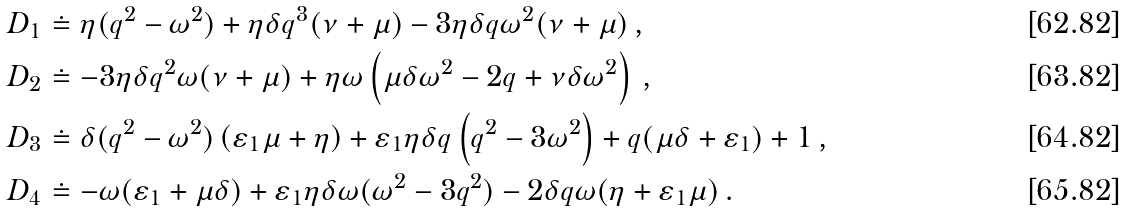<formula> <loc_0><loc_0><loc_500><loc_500>D _ { 1 } & \doteq \eta ( q ^ { 2 } - \omega ^ { 2 } ) + \eta \delta q ^ { 3 } ( \nu + \mu ) - 3 \eta \delta q \omega ^ { 2 } ( \nu + \mu ) \, , \\ D _ { 2 } & \doteq - 3 \eta \delta q ^ { 2 } \omega ( \nu + \mu ) + \eta \omega \left ( \mu \delta \omega ^ { 2 } - 2 q + \nu \delta \omega ^ { 2 } \right ) \, , \\ D _ { 3 } & \doteq \delta ( q ^ { 2 } - \omega ^ { 2 } ) \left ( \varepsilon _ { 1 } \mu + \eta \right ) + \varepsilon _ { 1 } \eta \delta q \left ( q ^ { 2 } - 3 \omega ^ { 2 } \right ) + q ( \mu \delta + \varepsilon _ { 1 } ) + 1 \, , \\ D _ { 4 } & \doteq - \omega ( \varepsilon _ { 1 } + \mu \delta ) + \varepsilon _ { 1 } \eta \delta \omega ( \omega ^ { 2 } - 3 q ^ { 2 } ) - 2 \delta q \omega ( \eta + \varepsilon _ { 1 } \mu ) \, .</formula> 